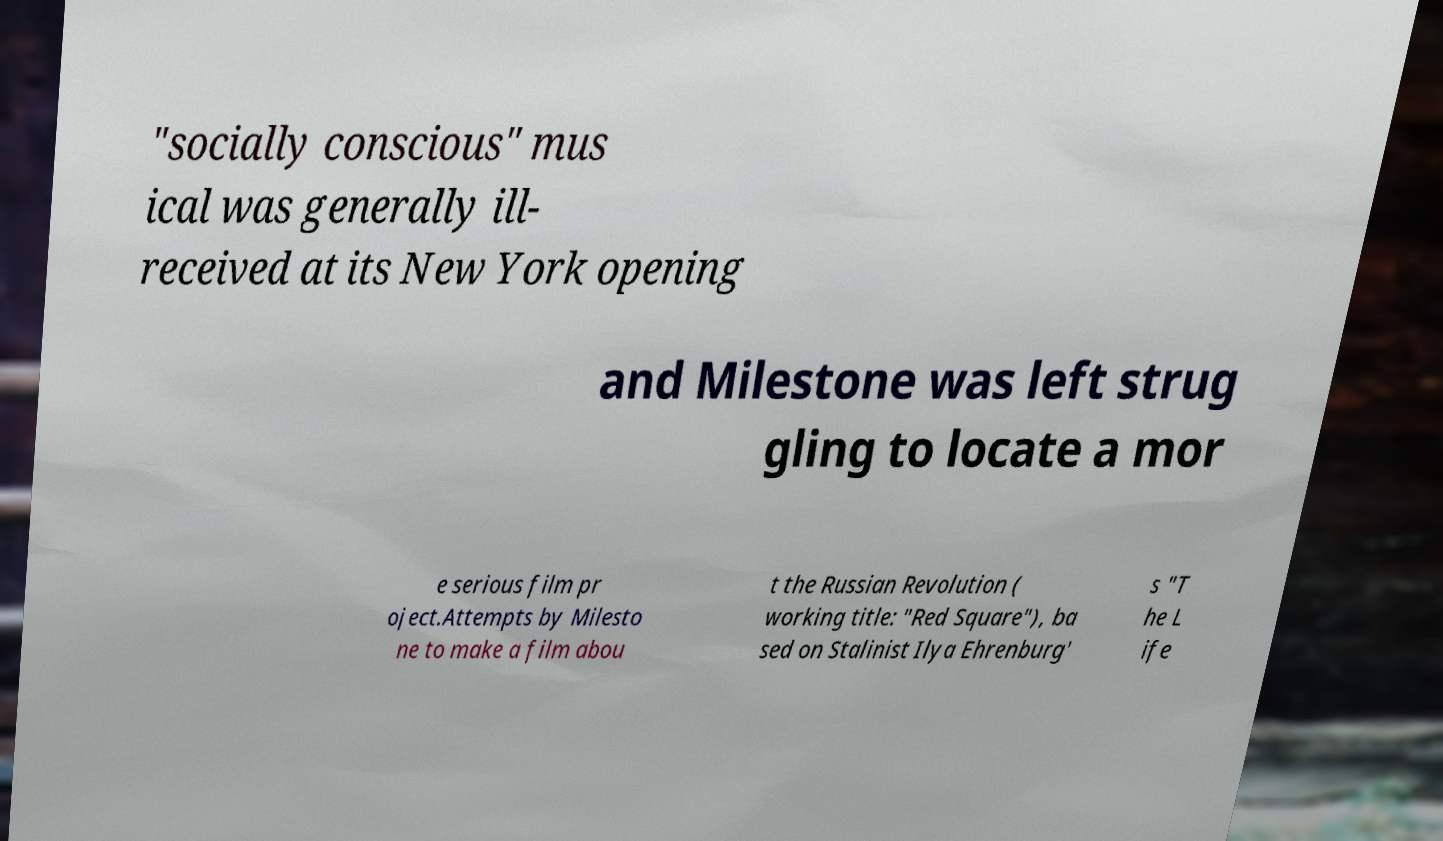Could you extract and type out the text from this image? "socially conscious" mus ical was generally ill- received at its New York opening and Milestone was left strug gling to locate a mor e serious film pr oject.Attempts by Milesto ne to make a film abou t the Russian Revolution ( working title: "Red Square"), ba sed on Stalinist Ilya Ehrenburg' s "T he L ife 